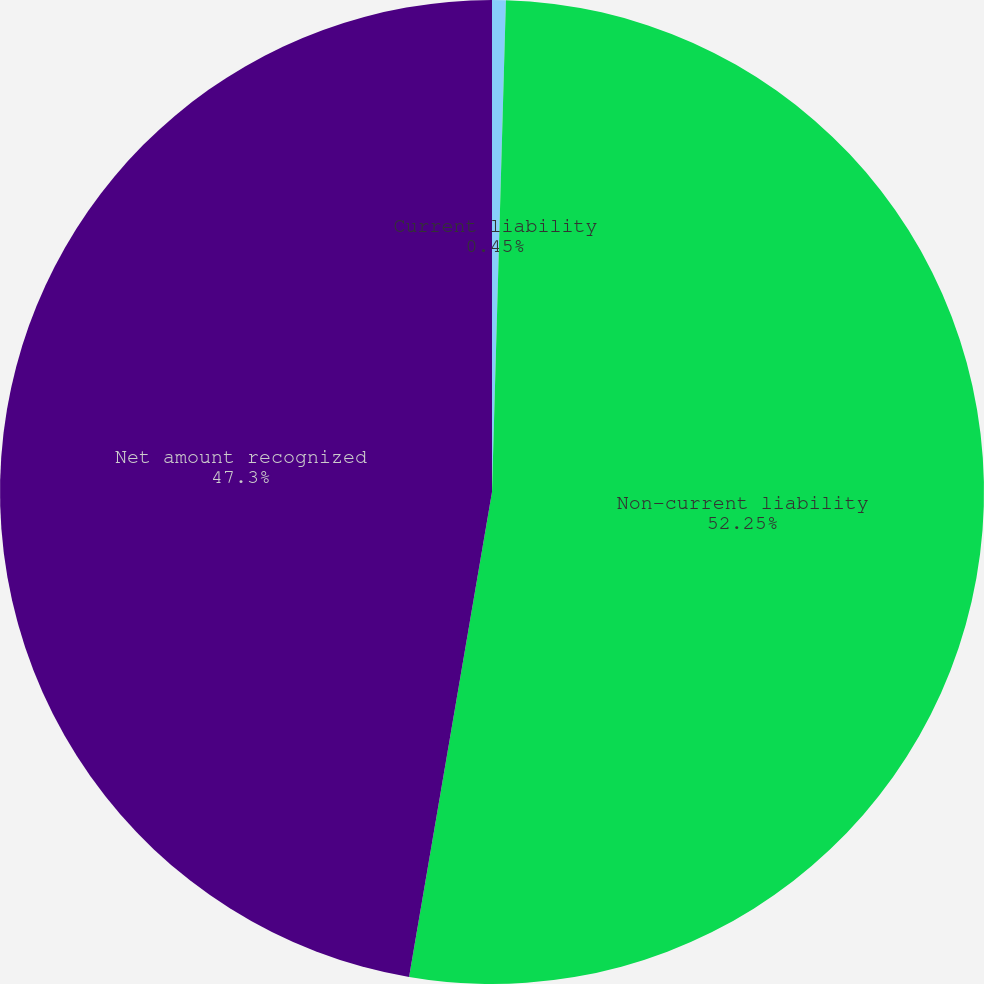<chart> <loc_0><loc_0><loc_500><loc_500><pie_chart><fcel>Current liability<fcel>Non-current liability<fcel>Net amount recognized<nl><fcel>0.45%<fcel>52.24%<fcel>47.3%<nl></chart> 